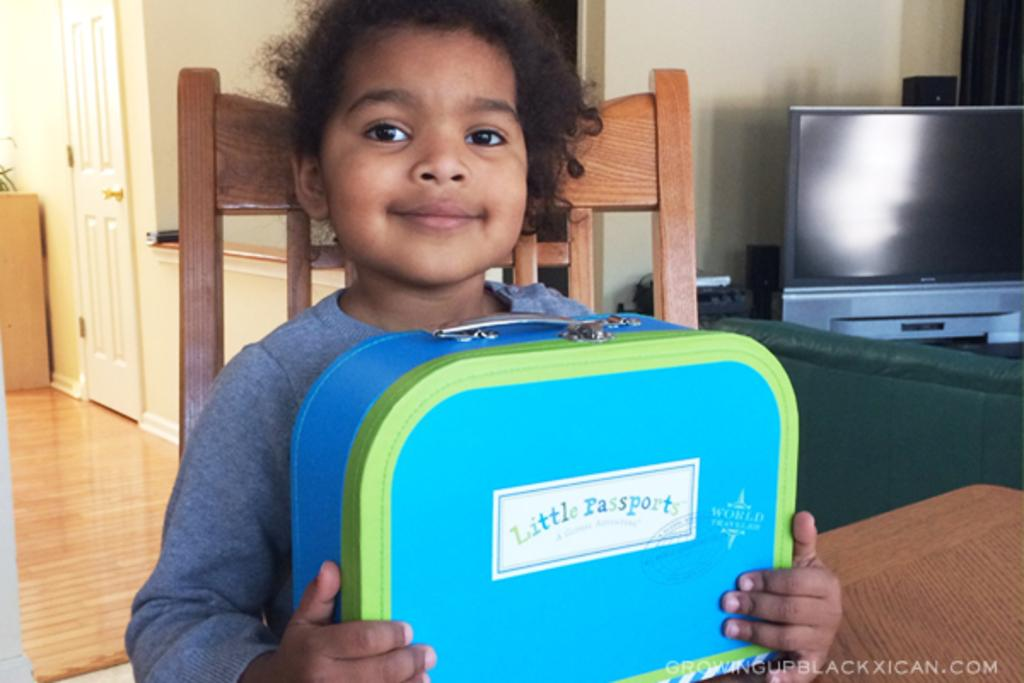Who is the main subject in the image? There is a little boy in the image. What is the boy holding in the image? The boy is holding a bag. Where is the boy sitting in the image? The boy is sitting on a chair. What electronic device can be seen in the image? There is a TV on a table in the image. What type of furniture is present in the image? There is a couch in the image. What is located on the left side of the image? There is a door on the left side of the image. What type of toothbrush is the boy using in the image? There is no toothbrush present in the image. What is the air quality like in the room depicted in the image? The image does not provide information about the air quality in the room. 